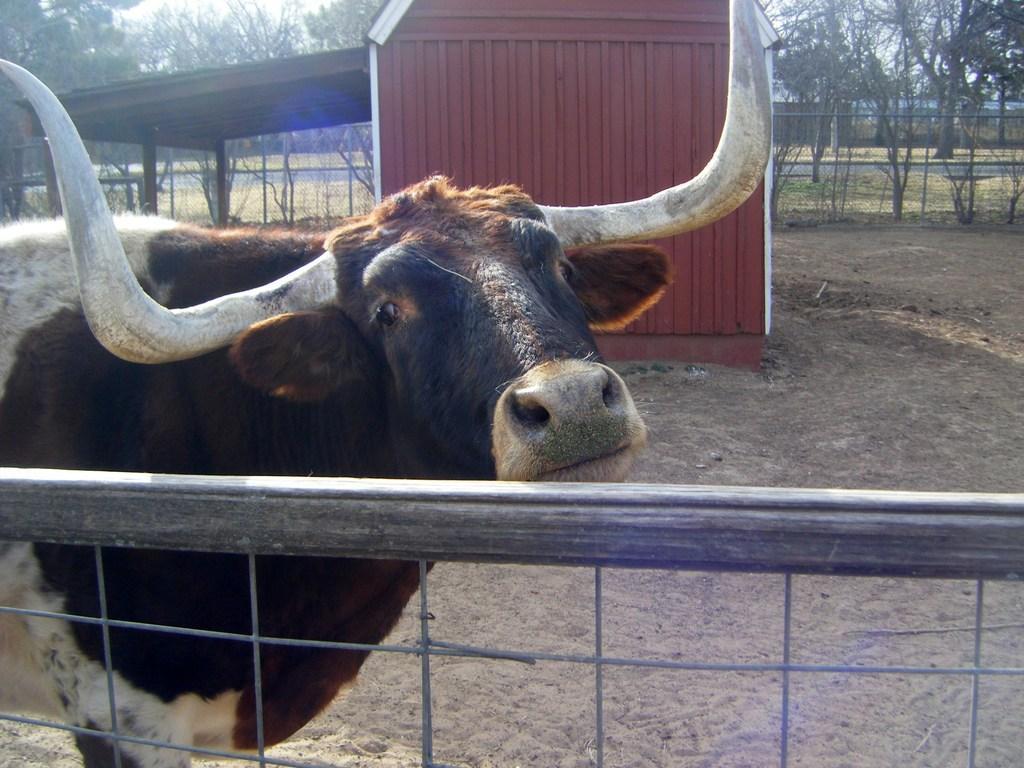Please provide a concise description of this image. In the picture i can see a animal which is white and brown in colour and in the background i can see a shed and some trees. 